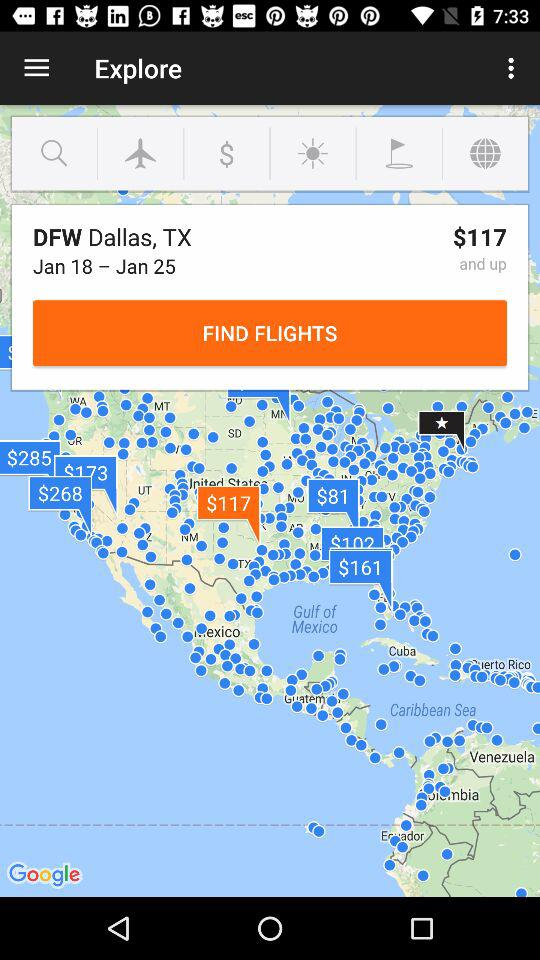What is the name of the airport? The name of the airport is DFW Dallas, TX. 